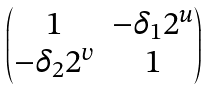<formula> <loc_0><loc_0><loc_500><loc_500>\begin{pmatrix} 1 & - \delta _ { 1 } 2 ^ { u } \\ - \delta _ { 2 } 2 ^ { v } & 1 \end{pmatrix}</formula> 